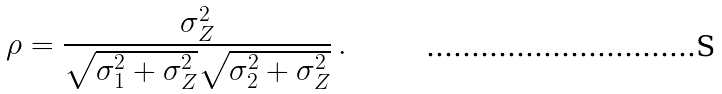Convert formula to latex. <formula><loc_0><loc_0><loc_500><loc_500>\rho = \frac { \sigma _ { Z } ^ { 2 } } { \sqrt { \sigma _ { 1 } ^ { 2 } + \sigma _ { Z } ^ { 2 } } \sqrt { \sigma _ { 2 } ^ { 2 } + \sigma _ { Z } ^ { 2 } } } \, .</formula> 